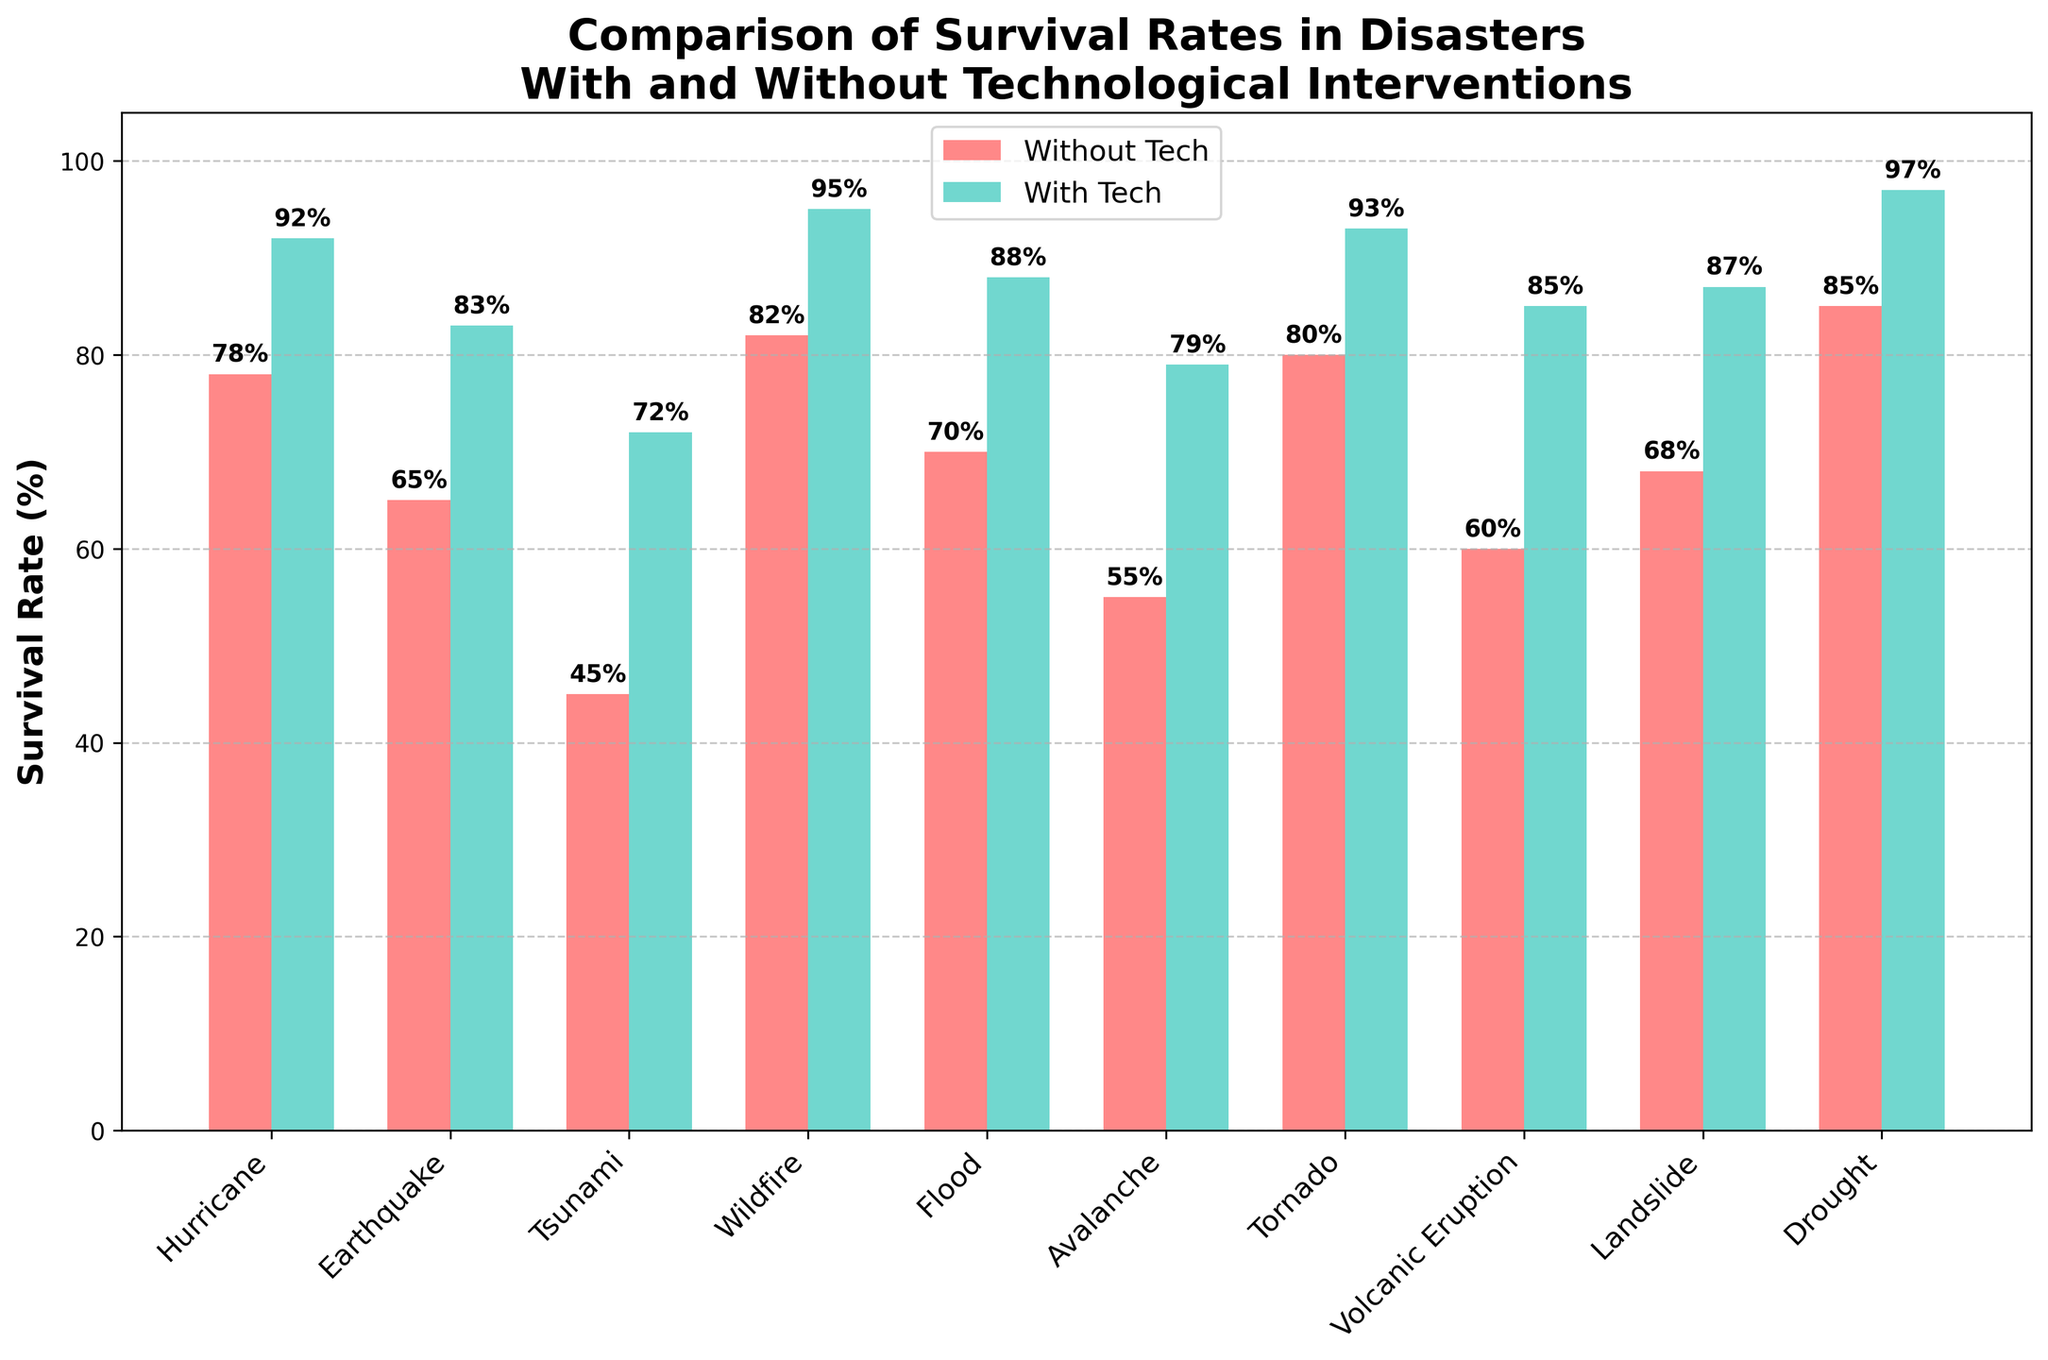What's the difference in survival rates between disasters with technological interventions and without for hurricanes? To find this, subtract the survival rate without tech from the survival rate with tech for hurricanes, which is 92% - 78%.
Answer: 14% Which disaster shows the highest improvement in survival rates due to technological interventions? Calculate the difference in survival rates with and without technological interventions for each disaster and find the maximum value. The wildfire has the highest improvement with a difference of 95% - 82%.
Answer: Wildfire For which disaster type is the percentage increase in survival rates the smallest? Calculate the percentage increase for each disaster using the formula (Survival Rate With Tech - Survival Rate Without Tech) / Survival Rate Without Tech, and identify the smallest value. The smallest percentage increase appears to be for the drought: (97% - 85%) / 85%.
Answer: Drought How do the survival rates for floods compare with and without technological interventions? Refer to the specific values for flood survival rates in terms of 'Without Tech' and 'With Tech' from the bars. The values are 70% and 88%.
Answer: 70% without tech, 88% with tech Among the disaster types, which one had the higher survival rate even without technological interventions? Look at the heights of the 'Without Tech' bars for each disaster type and identify the highest one. Drought has the highest survival rate without tech, at 85%.
Answer: Drought What's the average survival rate with technological interventions across all disaster types? Sum all the 'With Tech' survival rates and divide by the number of disaster types. Calculate (92 + 83 + 72 + 95 + 88 + 79 + 93 + 85 + 87 + 97) / 10. The average is (871 / 10).
Answer: 87.1% Compare the survival improvement between tornadoes and landslides due to technological interventions. Which disaster shows a higher improvement? Calculate the improvement for both disasters: Tornado (93% - 80%) and Landslide (87% - 68%), then compare which one is higher. For tornadoes, the improvement is 13%, and for landslides, it's 19%.
Answer: Landslide What is the color representing survival rates with technology, and what does this suggest about the impact of technology on survival rates visually? Look at the legend, the bar for survival rates with tech is colored green. This visual choice suggests that technological interventions have a positive impact on survival rates, making them significantly higher.
Answer: Green, Positive impact Which disaster type showed a survival rate without technological interventions below 50%? Scan the heights of the 'Without Tech' bars and identify any bars below the 50% mark. The tsunami survival rate without tech is 45%.
Answer: Tsunami What is the highest survival rate with technological interventions, and for which disaster type is it? Check for the tallest green bar, which represents the highest survival rate with tech. The highest is for drought at 97%.
Answer: 97%, Drought 